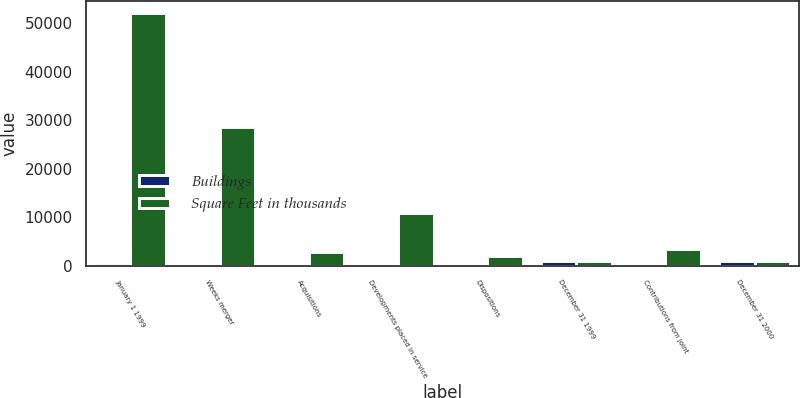Convert chart to OTSL. <chart><loc_0><loc_0><loc_500><loc_500><stacked_bar_chart><ecel><fcel>January 1 1999<fcel>Weeks merger<fcel>Acquisitions<fcel>Developments placed in service<fcel>Dispositions<fcel>December 31 1999<fcel>Contributions from joint<fcel>December 31 2000<nl><fcel>Buildings<fcel>453<fcel>335<fcel>30<fcel>68<fcel>21<fcel>865<fcel>24<fcel>913<nl><fcel>Square Feet in thousands<fcel>52028<fcel>28569<fcel>2867<fcel>10928<fcel>1890<fcel>889<fcel>3331<fcel>889<nl></chart> 